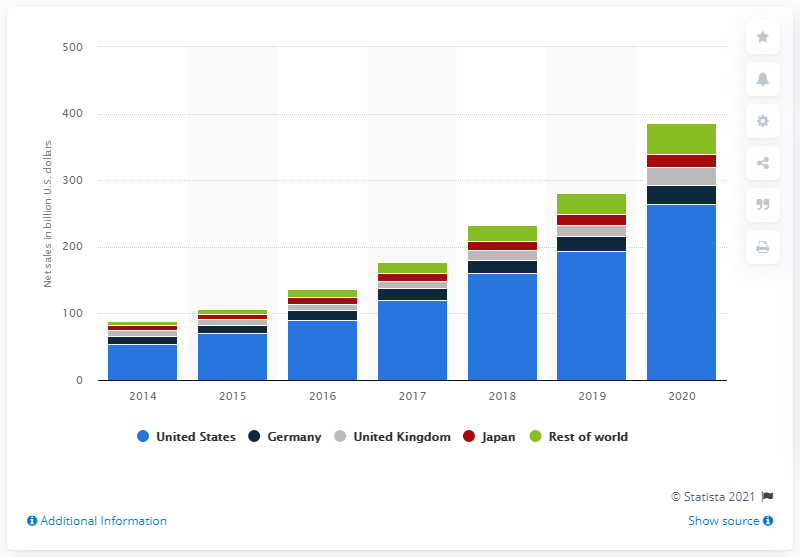List a handful of essential elements in this visual. In 2020, Amazon's net sales in the United States were approximately 263.52 billion dollars. Amazon's biggest market in 2020 was Germany. 